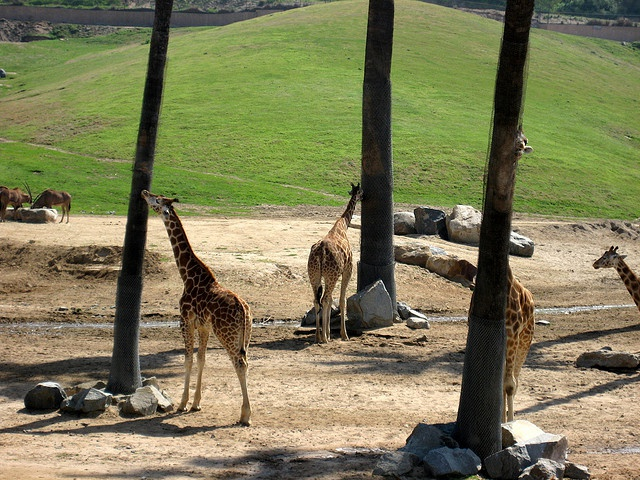Describe the objects in this image and their specific colors. I can see giraffe in darkgreen, black, maroon, and gray tones, giraffe in darkgreen, black, maroon, and gray tones, giraffe in darkgreen, maroon, gray, and black tones, and giraffe in darkgreen, black, maroon, and gray tones in this image. 